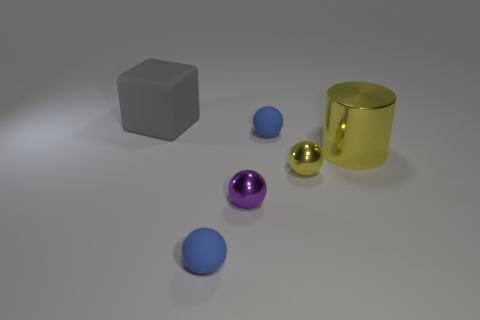Subtract all tiny yellow balls. How many balls are left? 3 Subtract all purple spheres. How many spheres are left? 3 Subtract all cylinders. How many objects are left? 5 Subtract 1 balls. How many balls are left? 3 Subtract all blue cylinders. How many cyan spheres are left? 0 Subtract 0 blue cylinders. How many objects are left? 6 Subtract all red spheres. Subtract all cyan cubes. How many spheres are left? 4 Subtract all gray matte things. Subtract all tiny yellow balls. How many objects are left? 4 Add 5 yellow shiny things. How many yellow shiny things are left? 7 Add 2 large yellow metallic things. How many large yellow metallic things exist? 3 